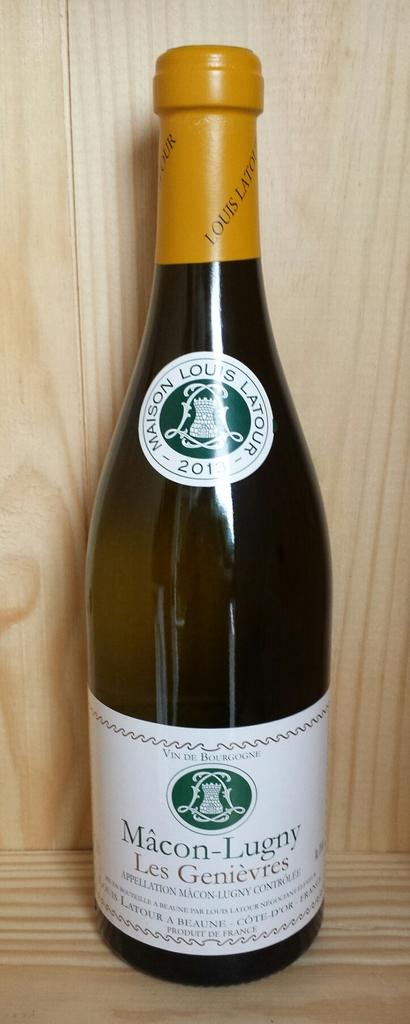What kind of wine?
Make the answer very short. Macon-lugny. 